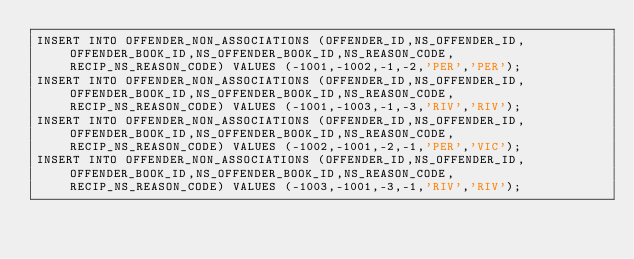<code> <loc_0><loc_0><loc_500><loc_500><_SQL_>INSERT INTO OFFENDER_NON_ASSOCIATIONS (OFFENDER_ID,NS_OFFENDER_ID,OFFENDER_BOOK_ID,NS_OFFENDER_BOOK_ID,NS_REASON_CODE, RECIP_NS_REASON_CODE) VALUES (-1001,-1002,-1,-2,'PER','PER');
INSERT INTO OFFENDER_NON_ASSOCIATIONS (OFFENDER_ID,NS_OFFENDER_ID,OFFENDER_BOOK_ID,NS_OFFENDER_BOOK_ID,NS_REASON_CODE, RECIP_NS_REASON_CODE) VALUES (-1001,-1003,-1,-3,'RIV','RIV');
INSERT INTO OFFENDER_NON_ASSOCIATIONS (OFFENDER_ID,NS_OFFENDER_ID,OFFENDER_BOOK_ID,NS_OFFENDER_BOOK_ID,NS_REASON_CODE, RECIP_NS_REASON_CODE) VALUES (-1002,-1001,-2,-1,'PER','VIC');
INSERT INTO OFFENDER_NON_ASSOCIATIONS (OFFENDER_ID,NS_OFFENDER_ID,OFFENDER_BOOK_ID,NS_OFFENDER_BOOK_ID,NS_REASON_CODE, RECIP_NS_REASON_CODE) VALUES (-1003,-1001,-3,-1,'RIV','RIV');
</code> 